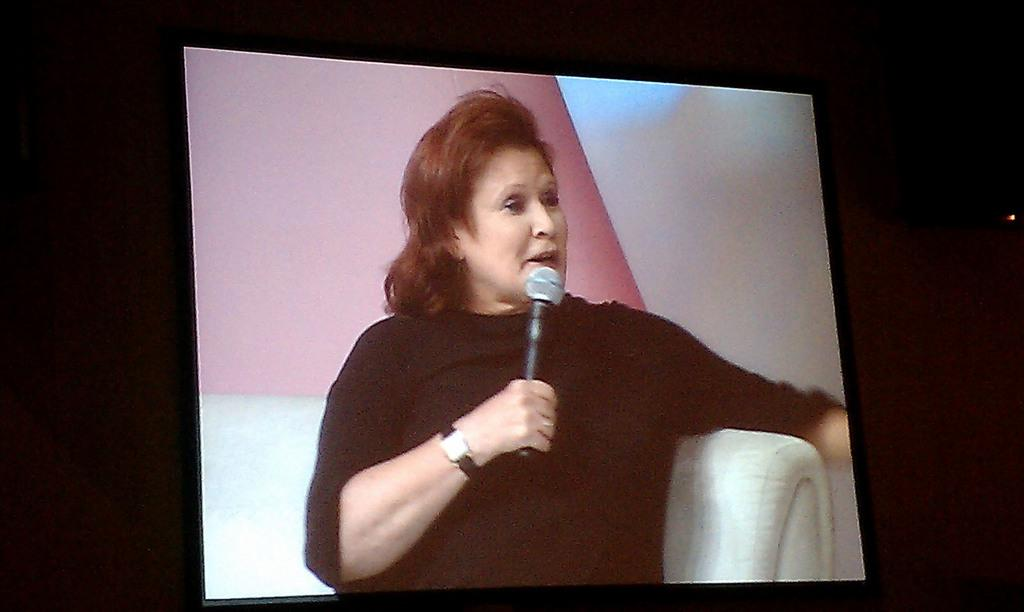What is the main subject of the image? There is a person in the image. What is the person wearing? The person is wearing a black dress. What objects is the person holding? The person is holding a watch and a microphone. What piece of furniture is the person sitting on? The person is sitting on a couch. What type of bread is the person using as a loaf in the image? There is no bread or loaf present in the image. What type of legal authority is the person portraying in the image? There is no indication of the person portraying any legal authority in the image. 